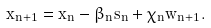<formula> <loc_0><loc_0><loc_500><loc_500>x _ { n + 1 } = x _ { n } - \beta _ { n } s _ { n } + \chi _ { n } w _ { n + 1 } .</formula> 